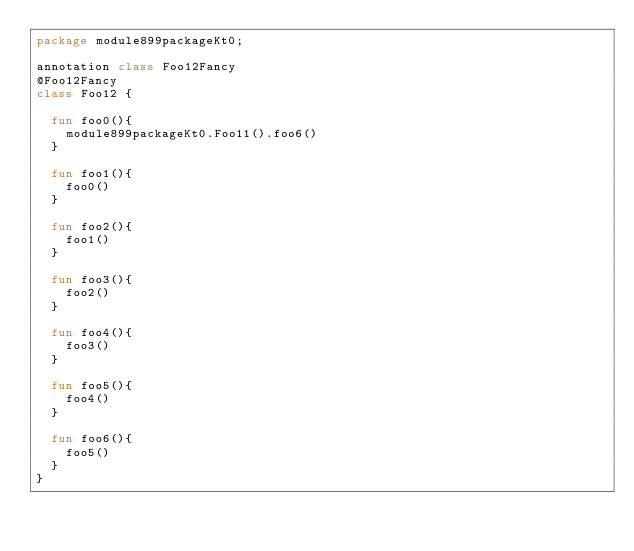Convert code to text. <code><loc_0><loc_0><loc_500><loc_500><_Kotlin_>package module899packageKt0;

annotation class Foo12Fancy
@Foo12Fancy
class Foo12 {

  fun foo0(){
    module899packageKt0.Foo11().foo6()
  }

  fun foo1(){
    foo0()
  }

  fun foo2(){
    foo1()
  }

  fun foo3(){
    foo2()
  }

  fun foo4(){
    foo3()
  }

  fun foo5(){
    foo4()
  }

  fun foo6(){
    foo5()
  }
}</code> 